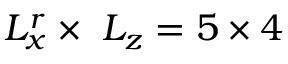Convert formula to latex. <formula><loc_0><loc_0><loc_500><loc_500>L _ { x } ^ { r } \times \ L _ { z } = 5 \times 4</formula> 